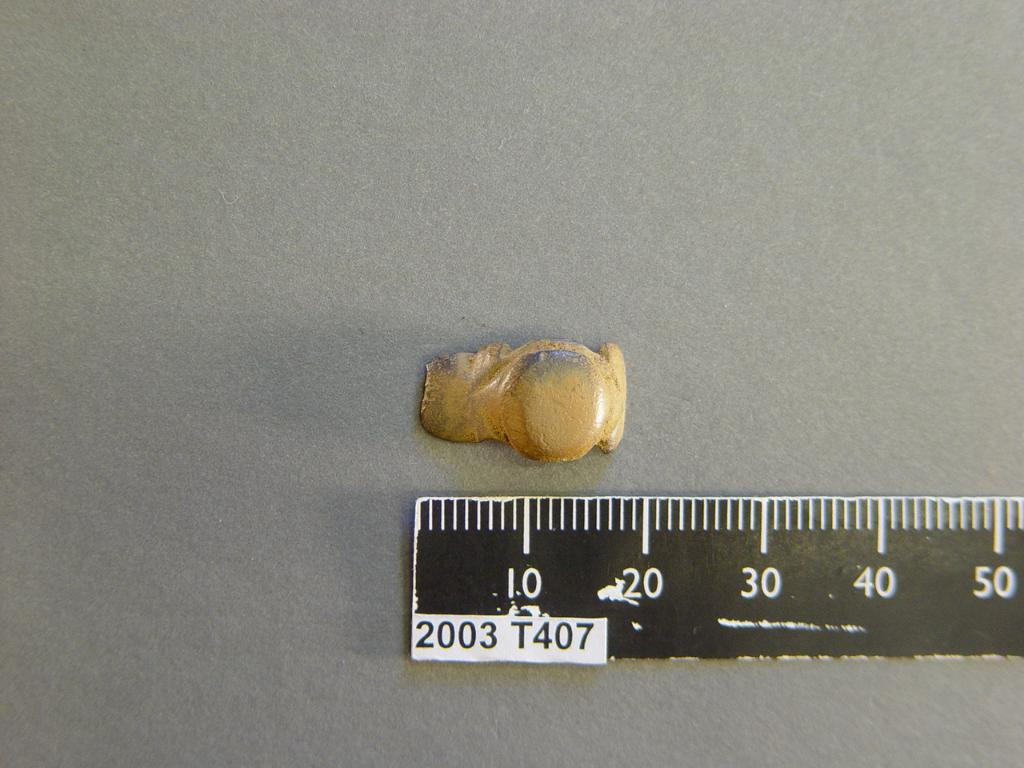<image>
Summarize the visual content of the image. A fragment laying next to a measuring tool with a length of 20. 